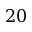Convert formula to latex. <formula><loc_0><loc_0><loc_500><loc_500>2 0</formula> 